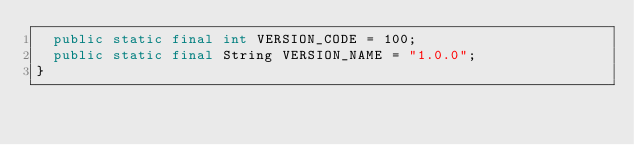Convert code to text. <code><loc_0><loc_0><loc_500><loc_500><_Java_>  public static final int VERSION_CODE = 100;
  public static final String VERSION_NAME = "1.0.0";
}
</code> 